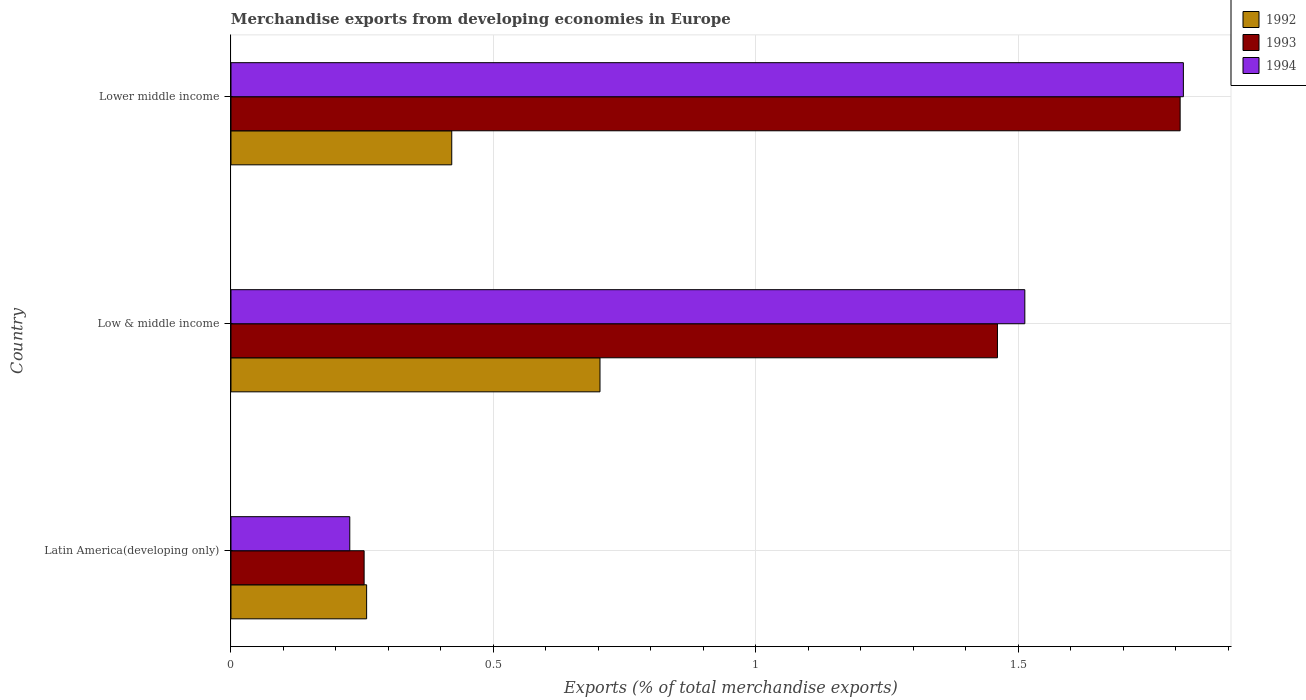How many different coloured bars are there?
Ensure brevity in your answer.  3. Are the number of bars per tick equal to the number of legend labels?
Your response must be concise. Yes. How many bars are there on the 2nd tick from the top?
Offer a terse response. 3. How many bars are there on the 1st tick from the bottom?
Your answer should be very brief. 3. What is the label of the 3rd group of bars from the top?
Offer a very short reply. Latin America(developing only). In how many cases, is the number of bars for a given country not equal to the number of legend labels?
Your answer should be compact. 0. What is the percentage of total merchandise exports in 1993 in Lower middle income?
Provide a short and direct response. 1.81. Across all countries, what is the maximum percentage of total merchandise exports in 1992?
Your answer should be compact. 0.7. Across all countries, what is the minimum percentage of total merchandise exports in 1993?
Offer a very short reply. 0.25. In which country was the percentage of total merchandise exports in 1992 maximum?
Make the answer very short. Low & middle income. In which country was the percentage of total merchandise exports in 1992 minimum?
Your answer should be compact. Latin America(developing only). What is the total percentage of total merchandise exports in 1994 in the graph?
Offer a very short reply. 3.55. What is the difference between the percentage of total merchandise exports in 1994 in Latin America(developing only) and that in Lower middle income?
Ensure brevity in your answer.  -1.59. What is the difference between the percentage of total merchandise exports in 1993 in Lower middle income and the percentage of total merchandise exports in 1992 in Latin America(developing only)?
Your answer should be compact. 1.55. What is the average percentage of total merchandise exports in 1992 per country?
Make the answer very short. 0.46. What is the difference between the percentage of total merchandise exports in 1992 and percentage of total merchandise exports in 1994 in Latin America(developing only)?
Keep it short and to the point. 0.03. What is the ratio of the percentage of total merchandise exports in 1992 in Latin America(developing only) to that in Lower middle income?
Provide a short and direct response. 0.61. What is the difference between the highest and the second highest percentage of total merchandise exports in 1994?
Your answer should be very brief. 0.3. What is the difference between the highest and the lowest percentage of total merchandise exports in 1992?
Provide a succinct answer. 0.44. In how many countries, is the percentage of total merchandise exports in 1992 greater than the average percentage of total merchandise exports in 1992 taken over all countries?
Your answer should be compact. 1. Is the sum of the percentage of total merchandise exports in 1993 in Latin America(developing only) and Low & middle income greater than the maximum percentage of total merchandise exports in 1992 across all countries?
Give a very brief answer. Yes. What does the 2nd bar from the top in Lower middle income represents?
Provide a succinct answer. 1993. How many bars are there?
Provide a succinct answer. 9. How many countries are there in the graph?
Provide a succinct answer. 3. What is the difference between two consecutive major ticks on the X-axis?
Keep it short and to the point. 0.5. Does the graph contain any zero values?
Give a very brief answer. No. What is the title of the graph?
Your answer should be compact. Merchandise exports from developing economies in Europe. Does "1985" appear as one of the legend labels in the graph?
Offer a terse response. No. What is the label or title of the X-axis?
Make the answer very short. Exports (% of total merchandise exports). What is the Exports (% of total merchandise exports) in 1992 in Latin America(developing only)?
Your response must be concise. 0.26. What is the Exports (% of total merchandise exports) of 1993 in Latin America(developing only)?
Your answer should be very brief. 0.25. What is the Exports (% of total merchandise exports) in 1994 in Latin America(developing only)?
Give a very brief answer. 0.23. What is the Exports (% of total merchandise exports) in 1992 in Low & middle income?
Provide a succinct answer. 0.7. What is the Exports (% of total merchandise exports) in 1993 in Low & middle income?
Your answer should be very brief. 1.46. What is the Exports (% of total merchandise exports) in 1994 in Low & middle income?
Provide a succinct answer. 1.51. What is the Exports (% of total merchandise exports) in 1992 in Lower middle income?
Offer a very short reply. 0.42. What is the Exports (% of total merchandise exports) of 1993 in Lower middle income?
Make the answer very short. 1.81. What is the Exports (% of total merchandise exports) in 1994 in Lower middle income?
Your response must be concise. 1.81. Across all countries, what is the maximum Exports (% of total merchandise exports) in 1992?
Make the answer very short. 0.7. Across all countries, what is the maximum Exports (% of total merchandise exports) of 1993?
Offer a terse response. 1.81. Across all countries, what is the maximum Exports (% of total merchandise exports) of 1994?
Give a very brief answer. 1.81. Across all countries, what is the minimum Exports (% of total merchandise exports) of 1992?
Your answer should be compact. 0.26. Across all countries, what is the minimum Exports (% of total merchandise exports) of 1993?
Make the answer very short. 0.25. Across all countries, what is the minimum Exports (% of total merchandise exports) in 1994?
Offer a very short reply. 0.23. What is the total Exports (% of total merchandise exports) in 1992 in the graph?
Give a very brief answer. 1.38. What is the total Exports (% of total merchandise exports) in 1993 in the graph?
Offer a very short reply. 3.52. What is the total Exports (% of total merchandise exports) in 1994 in the graph?
Provide a succinct answer. 3.55. What is the difference between the Exports (% of total merchandise exports) in 1992 in Latin America(developing only) and that in Low & middle income?
Keep it short and to the point. -0.44. What is the difference between the Exports (% of total merchandise exports) in 1993 in Latin America(developing only) and that in Low & middle income?
Ensure brevity in your answer.  -1.21. What is the difference between the Exports (% of total merchandise exports) in 1994 in Latin America(developing only) and that in Low & middle income?
Your answer should be compact. -1.29. What is the difference between the Exports (% of total merchandise exports) in 1992 in Latin America(developing only) and that in Lower middle income?
Make the answer very short. -0.16. What is the difference between the Exports (% of total merchandise exports) in 1993 in Latin America(developing only) and that in Lower middle income?
Keep it short and to the point. -1.55. What is the difference between the Exports (% of total merchandise exports) in 1994 in Latin America(developing only) and that in Lower middle income?
Give a very brief answer. -1.59. What is the difference between the Exports (% of total merchandise exports) in 1992 in Low & middle income and that in Lower middle income?
Give a very brief answer. 0.28. What is the difference between the Exports (% of total merchandise exports) of 1993 in Low & middle income and that in Lower middle income?
Provide a short and direct response. -0.35. What is the difference between the Exports (% of total merchandise exports) in 1994 in Low & middle income and that in Lower middle income?
Give a very brief answer. -0.3. What is the difference between the Exports (% of total merchandise exports) of 1992 in Latin America(developing only) and the Exports (% of total merchandise exports) of 1993 in Low & middle income?
Keep it short and to the point. -1.2. What is the difference between the Exports (% of total merchandise exports) of 1992 in Latin America(developing only) and the Exports (% of total merchandise exports) of 1994 in Low & middle income?
Provide a succinct answer. -1.25. What is the difference between the Exports (% of total merchandise exports) of 1993 in Latin America(developing only) and the Exports (% of total merchandise exports) of 1994 in Low & middle income?
Provide a short and direct response. -1.26. What is the difference between the Exports (% of total merchandise exports) in 1992 in Latin America(developing only) and the Exports (% of total merchandise exports) in 1993 in Lower middle income?
Make the answer very short. -1.55. What is the difference between the Exports (% of total merchandise exports) in 1992 in Latin America(developing only) and the Exports (% of total merchandise exports) in 1994 in Lower middle income?
Your response must be concise. -1.56. What is the difference between the Exports (% of total merchandise exports) of 1993 in Latin America(developing only) and the Exports (% of total merchandise exports) of 1994 in Lower middle income?
Ensure brevity in your answer.  -1.56. What is the difference between the Exports (% of total merchandise exports) in 1992 in Low & middle income and the Exports (% of total merchandise exports) in 1993 in Lower middle income?
Your answer should be compact. -1.11. What is the difference between the Exports (% of total merchandise exports) in 1992 in Low & middle income and the Exports (% of total merchandise exports) in 1994 in Lower middle income?
Keep it short and to the point. -1.11. What is the difference between the Exports (% of total merchandise exports) of 1993 in Low & middle income and the Exports (% of total merchandise exports) of 1994 in Lower middle income?
Your answer should be compact. -0.35. What is the average Exports (% of total merchandise exports) of 1992 per country?
Make the answer very short. 0.46. What is the average Exports (% of total merchandise exports) of 1993 per country?
Your response must be concise. 1.17. What is the average Exports (% of total merchandise exports) of 1994 per country?
Provide a short and direct response. 1.18. What is the difference between the Exports (% of total merchandise exports) in 1992 and Exports (% of total merchandise exports) in 1993 in Latin America(developing only)?
Offer a terse response. 0. What is the difference between the Exports (% of total merchandise exports) in 1992 and Exports (% of total merchandise exports) in 1994 in Latin America(developing only)?
Make the answer very short. 0.03. What is the difference between the Exports (% of total merchandise exports) of 1993 and Exports (% of total merchandise exports) of 1994 in Latin America(developing only)?
Your response must be concise. 0.03. What is the difference between the Exports (% of total merchandise exports) in 1992 and Exports (% of total merchandise exports) in 1993 in Low & middle income?
Offer a terse response. -0.76. What is the difference between the Exports (% of total merchandise exports) in 1992 and Exports (% of total merchandise exports) in 1994 in Low & middle income?
Make the answer very short. -0.81. What is the difference between the Exports (% of total merchandise exports) in 1993 and Exports (% of total merchandise exports) in 1994 in Low & middle income?
Keep it short and to the point. -0.05. What is the difference between the Exports (% of total merchandise exports) in 1992 and Exports (% of total merchandise exports) in 1993 in Lower middle income?
Your response must be concise. -1.39. What is the difference between the Exports (% of total merchandise exports) in 1992 and Exports (% of total merchandise exports) in 1994 in Lower middle income?
Make the answer very short. -1.39. What is the difference between the Exports (% of total merchandise exports) in 1993 and Exports (% of total merchandise exports) in 1994 in Lower middle income?
Your response must be concise. -0.01. What is the ratio of the Exports (% of total merchandise exports) in 1992 in Latin America(developing only) to that in Low & middle income?
Your answer should be compact. 0.37. What is the ratio of the Exports (% of total merchandise exports) in 1993 in Latin America(developing only) to that in Low & middle income?
Your response must be concise. 0.17. What is the ratio of the Exports (% of total merchandise exports) in 1994 in Latin America(developing only) to that in Low & middle income?
Keep it short and to the point. 0.15. What is the ratio of the Exports (% of total merchandise exports) in 1992 in Latin America(developing only) to that in Lower middle income?
Your response must be concise. 0.61. What is the ratio of the Exports (% of total merchandise exports) of 1993 in Latin America(developing only) to that in Lower middle income?
Your answer should be compact. 0.14. What is the ratio of the Exports (% of total merchandise exports) of 1994 in Latin America(developing only) to that in Lower middle income?
Offer a very short reply. 0.12. What is the ratio of the Exports (% of total merchandise exports) in 1992 in Low & middle income to that in Lower middle income?
Offer a very short reply. 1.67. What is the ratio of the Exports (% of total merchandise exports) of 1993 in Low & middle income to that in Lower middle income?
Offer a terse response. 0.81. What is the ratio of the Exports (% of total merchandise exports) in 1994 in Low & middle income to that in Lower middle income?
Provide a succinct answer. 0.83. What is the difference between the highest and the second highest Exports (% of total merchandise exports) of 1992?
Your response must be concise. 0.28. What is the difference between the highest and the second highest Exports (% of total merchandise exports) of 1993?
Give a very brief answer. 0.35. What is the difference between the highest and the second highest Exports (% of total merchandise exports) of 1994?
Offer a very short reply. 0.3. What is the difference between the highest and the lowest Exports (% of total merchandise exports) in 1992?
Ensure brevity in your answer.  0.44. What is the difference between the highest and the lowest Exports (% of total merchandise exports) in 1993?
Provide a succinct answer. 1.55. What is the difference between the highest and the lowest Exports (% of total merchandise exports) in 1994?
Offer a terse response. 1.59. 